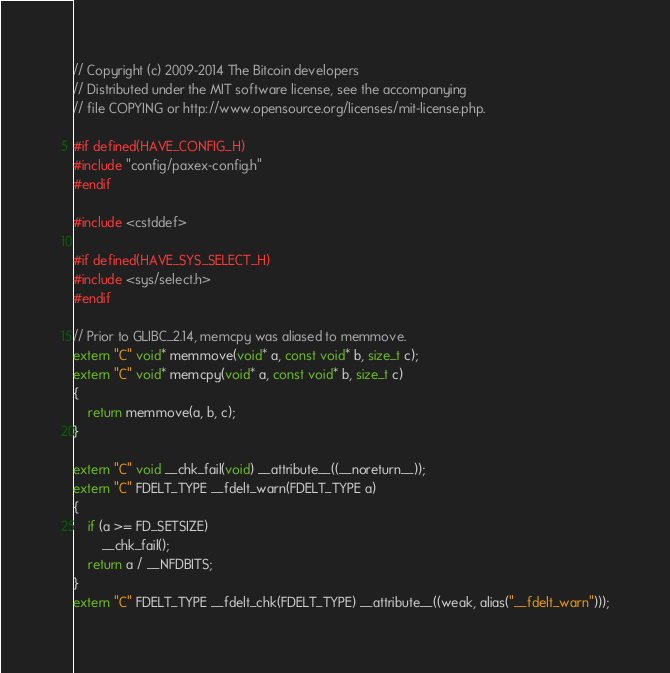Convert code to text. <code><loc_0><loc_0><loc_500><loc_500><_C++_>// Copyright (c) 2009-2014 The Bitcoin developers
// Distributed under the MIT software license, see the accompanying
// file COPYING or http://www.opensource.org/licenses/mit-license.php.

#if defined(HAVE_CONFIG_H)
#include "config/paxex-config.h"
#endif

#include <cstddef>

#if defined(HAVE_SYS_SELECT_H)
#include <sys/select.h>
#endif

// Prior to GLIBC_2.14, memcpy was aliased to memmove.
extern "C" void* memmove(void* a, const void* b, size_t c);
extern "C" void* memcpy(void* a, const void* b, size_t c)
{
    return memmove(a, b, c);
}

extern "C" void __chk_fail(void) __attribute__((__noreturn__));
extern "C" FDELT_TYPE __fdelt_warn(FDELT_TYPE a)
{
    if (a >= FD_SETSIZE)
        __chk_fail();
    return a / __NFDBITS;
}
extern "C" FDELT_TYPE __fdelt_chk(FDELT_TYPE) __attribute__((weak, alias("__fdelt_warn")));
</code> 